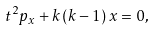<formula> <loc_0><loc_0><loc_500><loc_500>t ^ { 2 } p _ { x } + k \, ( k - 1 ) \, x = 0 ,</formula> 